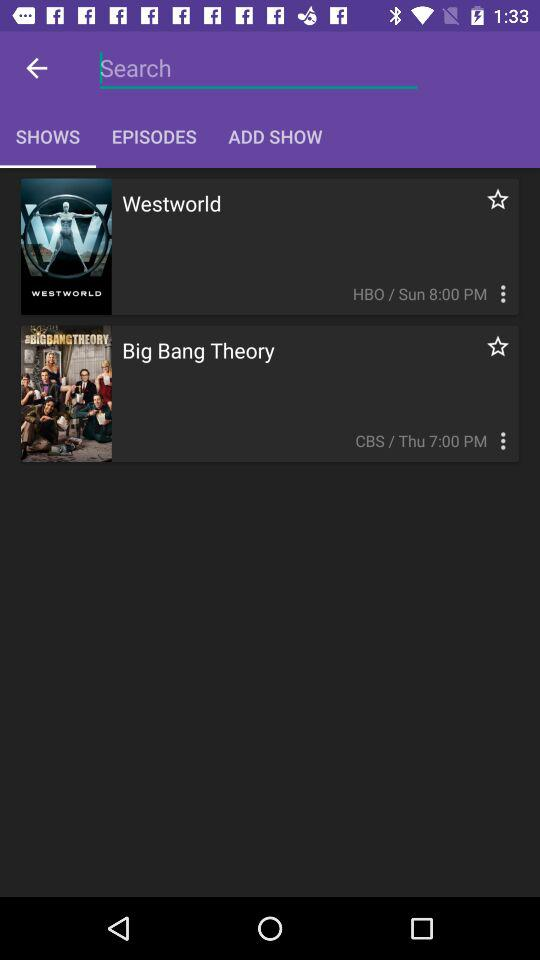What is the broadcast time of "Big Bang Theory"? The broadcast time is 7:00 PM. 